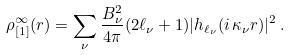<formula> <loc_0><loc_0><loc_500><loc_500>\rho _ { [ 1 ] } ^ { \infty } ( r ) = \sum _ { \nu } \frac { B _ { \nu } ^ { 2 } } { 4 \pi } ( 2 \ell _ { \nu } + 1 ) | h _ { \ell _ { \nu } } ( i \, \kappa _ { \nu } r ) | ^ { 2 } \, .</formula> 